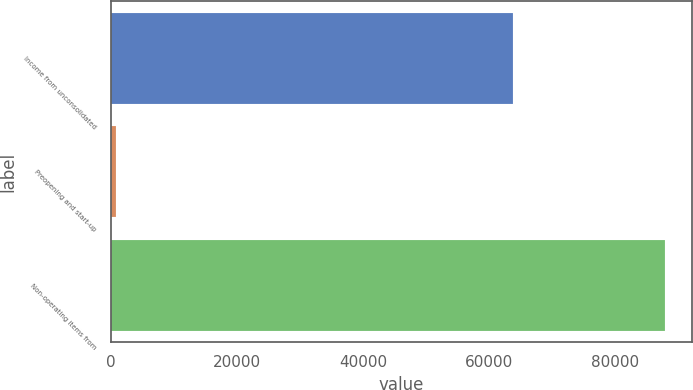<chart> <loc_0><loc_0><loc_500><loc_500><bar_chart><fcel>Income from unconsolidated<fcel>Preopening and start-up<fcel>Non-operating items from<nl><fcel>63836<fcel>917<fcel>87794<nl></chart> 